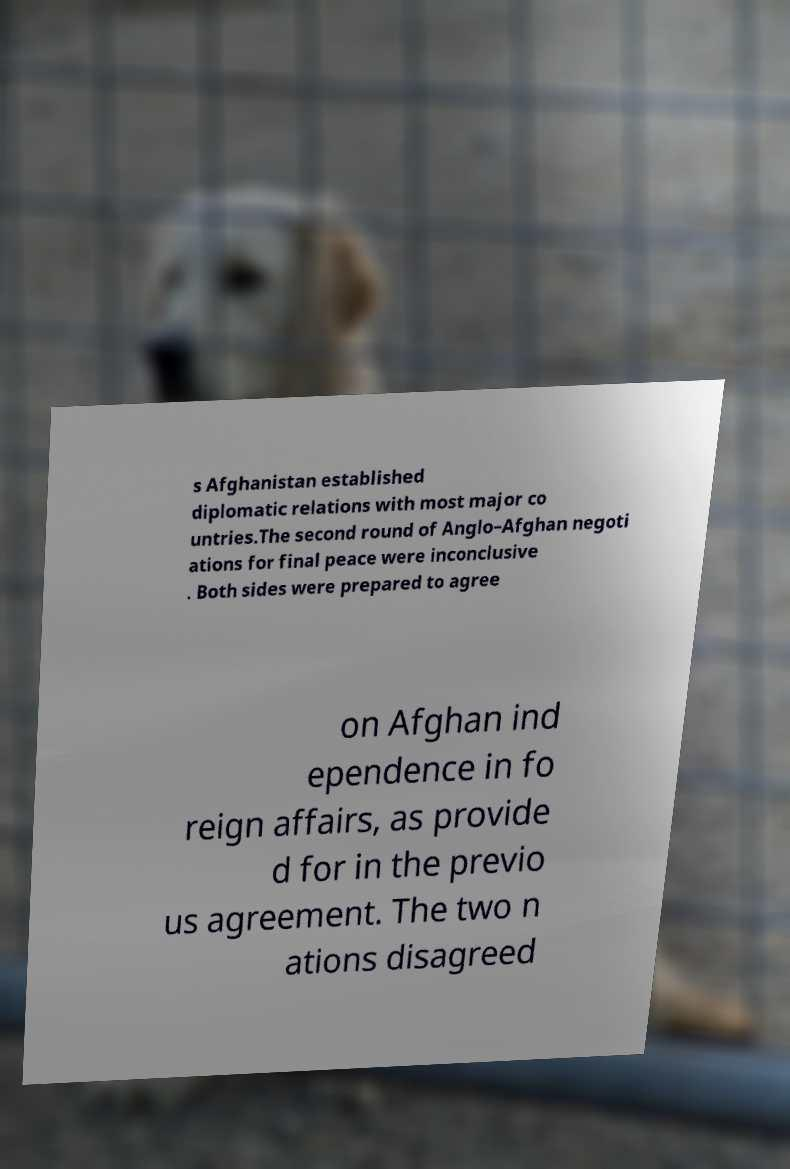Could you extract and type out the text from this image? s Afghanistan established diplomatic relations with most major co untries.The second round of Anglo–Afghan negoti ations for final peace were inconclusive . Both sides were prepared to agree on Afghan ind ependence in fo reign affairs, as provide d for in the previo us agreement. The two n ations disagreed 